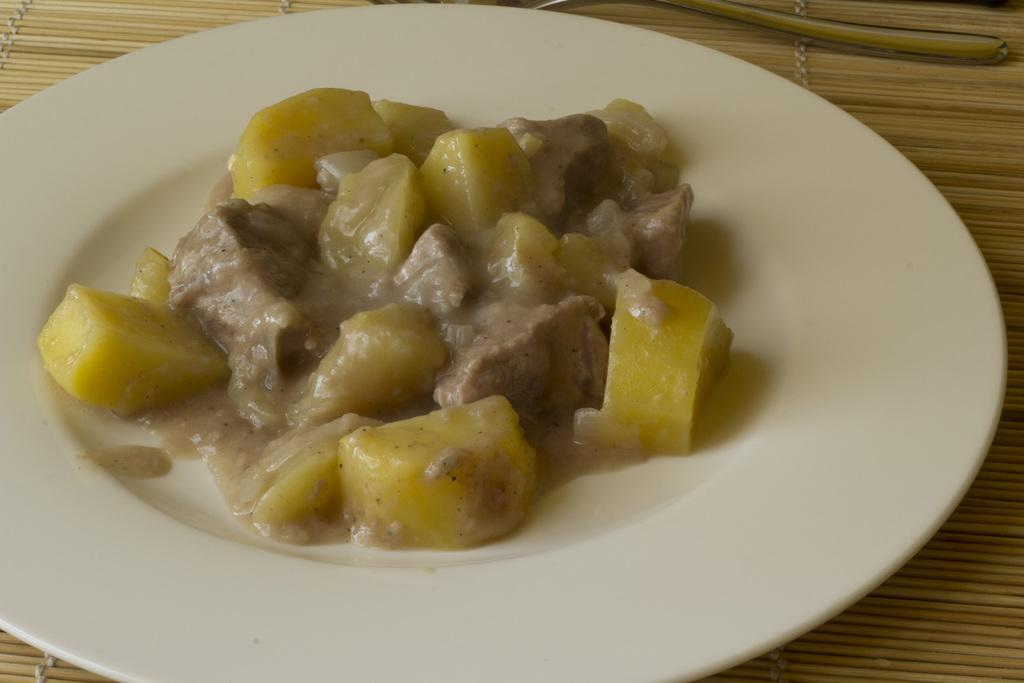What is present on the plate in the image? The plate contains a food item. Can you describe the appearance of the food item on the plate? The food item has yellow and brown colors. What angle does the work take in the image? There is no reference to work or an angle in the image, as it features a plate with a food item. 